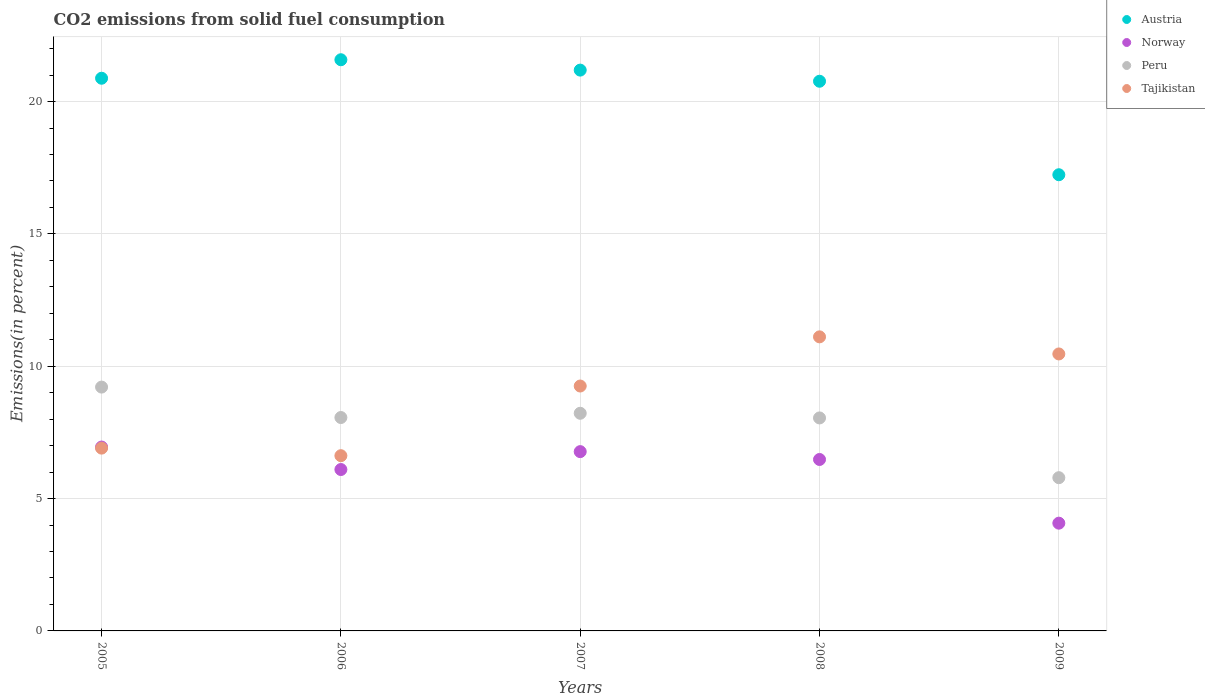Is the number of dotlines equal to the number of legend labels?
Your response must be concise. Yes. What is the total CO2 emitted in Austria in 2009?
Offer a terse response. 17.24. Across all years, what is the maximum total CO2 emitted in Norway?
Provide a short and direct response. 6.95. Across all years, what is the minimum total CO2 emitted in Norway?
Offer a terse response. 4.07. What is the total total CO2 emitted in Austria in the graph?
Provide a succinct answer. 101.66. What is the difference between the total CO2 emitted in Norway in 2008 and that in 2009?
Keep it short and to the point. 2.41. What is the difference between the total CO2 emitted in Austria in 2009 and the total CO2 emitted in Norway in 2007?
Offer a very short reply. 10.46. What is the average total CO2 emitted in Austria per year?
Your answer should be very brief. 20.33. In the year 2007, what is the difference between the total CO2 emitted in Austria and total CO2 emitted in Tajikistan?
Provide a succinct answer. 11.94. What is the ratio of the total CO2 emitted in Tajikistan in 2006 to that in 2008?
Offer a terse response. 0.6. Is the difference between the total CO2 emitted in Austria in 2005 and 2006 greater than the difference between the total CO2 emitted in Tajikistan in 2005 and 2006?
Your response must be concise. No. What is the difference between the highest and the second highest total CO2 emitted in Tajikistan?
Give a very brief answer. 0.65. What is the difference between the highest and the lowest total CO2 emitted in Tajikistan?
Give a very brief answer. 4.49. In how many years, is the total CO2 emitted in Austria greater than the average total CO2 emitted in Austria taken over all years?
Your answer should be very brief. 4. Is the sum of the total CO2 emitted in Norway in 2005 and 2008 greater than the maximum total CO2 emitted in Austria across all years?
Your answer should be very brief. No. Is it the case that in every year, the sum of the total CO2 emitted in Austria and total CO2 emitted in Norway  is greater than the total CO2 emitted in Tajikistan?
Your answer should be very brief. Yes. Is the total CO2 emitted in Peru strictly less than the total CO2 emitted in Norway over the years?
Offer a very short reply. No. How many dotlines are there?
Ensure brevity in your answer.  4. What is the difference between two consecutive major ticks on the Y-axis?
Keep it short and to the point. 5. Does the graph contain any zero values?
Provide a succinct answer. No. Does the graph contain grids?
Your answer should be compact. Yes. Where does the legend appear in the graph?
Your response must be concise. Top right. How are the legend labels stacked?
Ensure brevity in your answer.  Vertical. What is the title of the graph?
Keep it short and to the point. CO2 emissions from solid fuel consumption. What is the label or title of the X-axis?
Give a very brief answer. Years. What is the label or title of the Y-axis?
Ensure brevity in your answer.  Emissions(in percent). What is the Emissions(in percent) in Austria in 2005?
Provide a succinct answer. 20.88. What is the Emissions(in percent) in Norway in 2005?
Offer a terse response. 6.95. What is the Emissions(in percent) of Peru in 2005?
Your response must be concise. 9.21. What is the Emissions(in percent) in Tajikistan in 2005?
Keep it short and to the point. 6.91. What is the Emissions(in percent) of Austria in 2006?
Make the answer very short. 21.58. What is the Emissions(in percent) in Norway in 2006?
Make the answer very short. 6.1. What is the Emissions(in percent) of Peru in 2006?
Provide a short and direct response. 8.06. What is the Emissions(in percent) in Tajikistan in 2006?
Keep it short and to the point. 6.62. What is the Emissions(in percent) of Austria in 2007?
Provide a short and direct response. 21.19. What is the Emissions(in percent) of Norway in 2007?
Keep it short and to the point. 6.77. What is the Emissions(in percent) of Peru in 2007?
Provide a short and direct response. 8.22. What is the Emissions(in percent) in Tajikistan in 2007?
Provide a short and direct response. 9.25. What is the Emissions(in percent) of Austria in 2008?
Your answer should be very brief. 20.77. What is the Emissions(in percent) in Norway in 2008?
Your response must be concise. 6.48. What is the Emissions(in percent) of Peru in 2008?
Make the answer very short. 8.05. What is the Emissions(in percent) in Tajikistan in 2008?
Offer a very short reply. 11.11. What is the Emissions(in percent) in Austria in 2009?
Give a very brief answer. 17.24. What is the Emissions(in percent) in Norway in 2009?
Provide a short and direct response. 4.07. What is the Emissions(in percent) of Peru in 2009?
Give a very brief answer. 5.79. What is the Emissions(in percent) of Tajikistan in 2009?
Keep it short and to the point. 10.47. Across all years, what is the maximum Emissions(in percent) of Austria?
Offer a very short reply. 21.58. Across all years, what is the maximum Emissions(in percent) of Norway?
Make the answer very short. 6.95. Across all years, what is the maximum Emissions(in percent) in Peru?
Make the answer very short. 9.21. Across all years, what is the maximum Emissions(in percent) of Tajikistan?
Your answer should be compact. 11.11. Across all years, what is the minimum Emissions(in percent) in Austria?
Ensure brevity in your answer.  17.24. Across all years, what is the minimum Emissions(in percent) in Norway?
Your response must be concise. 4.07. Across all years, what is the minimum Emissions(in percent) of Peru?
Keep it short and to the point. 5.79. Across all years, what is the minimum Emissions(in percent) of Tajikistan?
Provide a succinct answer. 6.62. What is the total Emissions(in percent) in Austria in the graph?
Your answer should be compact. 101.66. What is the total Emissions(in percent) in Norway in the graph?
Your answer should be compact. 30.37. What is the total Emissions(in percent) in Peru in the graph?
Your response must be concise. 39.34. What is the total Emissions(in percent) in Tajikistan in the graph?
Offer a very short reply. 44.36. What is the difference between the Emissions(in percent) of Austria in 2005 and that in 2006?
Keep it short and to the point. -0.7. What is the difference between the Emissions(in percent) of Norway in 2005 and that in 2006?
Your answer should be very brief. 0.85. What is the difference between the Emissions(in percent) of Peru in 2005 and that in 2006?
Your answer should be compact. 1.15. What is the difference between the Emissions(in percent) in Tajikistan in 2005 and that in 2006?
Make the answer very short. 0.29. What is the difference between the Emissions(in percent) of Austria in 2005 and that in 2007?
Your answer should be very brief. -0.31. What is the difference between the Emissions(in percent) in Norway in 2005 and that in 2007?
Offer a terse response. 0.17. What is the difference between the Emissions(in percent) in Peru in 2005 and that in 2007?
Provide a short and direct response. 0.99. What is the difference between the Emissions(in percent) in Tajikistan in 2005 and that in 2007?
Provide a short and direct response. -2.35. What is the difference between the Emissions(in percent) in Austria in 2005 and that in 2008?
Make the answer very short. 0.11. What is the difference between the Emissions(in percent) in Norway in 2005 and that in 2008?
Provide a succinct answer. 0.47. What is the difference between the Emissions(in percent) in Peru in 2005 and that in 2008?
Give a very brief answer. 1.17. What is the difference between the Emissions(in percent) in Tajikistan in 2005 and that in 2008?
Ensure brevity in your answer.  -4.2. What is the difference between the Emissions(in percent) in Austria in 2005 and that in 2009?
Offer a very short reply. 3.65. What is the difference between the Emissions(in percent) of Norway in 2005 and that in 2009?
Your response must be concise. 2.88. What is the difference between the Emissions(in percent) in Peru in 2005 and that in 2009?
Offer a very short reply. 3.42. What is the difference between the Emissions(in percent) in Tajikistan in 2005 and that in 2009?
Your response must be concise. -3.56. What is the difference between the Emissions(in percent) of Austria in 2006 and that in 2007?
Your answer should be compact. 0.39. What is the difference between the Emissions(in percent) of Norway in 2006 and that in 2007?
Keep it short and to the point. -0.68. What is the difference between the Emissions(in percent) in Peru in 2006 and that in 2007?
Your response must be concise. -0.16. What is the difference between the Emissions(in percent) in Tajikistan in 2006 and that in 2007?
Provide a succinct answer. -2.63. What is the difference between the Emissions(in percent) of Austria in 2006 and that in 2008?
Your answer should be compact. 0.81. What is the difference between the Emissions(in percent) of Norway in 2006 and that in 2008?
Make the answer very short. -0.38. What is the difference between the Emissions(in percent) in Peru in 2006 and that in 2008?
Offer a terse response. 0.02. What is the difference between the Emissions(in percent) of Tajikistan in 2006 and that in 2008?
Offer a very short reply. -4.49. What is the difference between the Emissions(in percent) in Austria in 2006 and that in 2009?
Give a very brief answer. 4.34. What is the difference between the Emissions(in percent) of Norway in 2006 and that in 2009?
Make the answer very short. 2.03. What is the difference between the Emissions(in percent) of Peru in 2006 and that in 2009?
Make the answer very short. 2.27. What is the difference between the Emissions(in percent) of Tajikistan in 2006 and that in 2009?
Make the answer very short. -3.84. What is the difference between the Emissions(in percent) of Austria in 2007 and that in 2008?
Ensure brevity in your answer.  0.42. What is the difference between the Emissions(in percent) of Norway in 2007 and that in 2008?
Provide a short and direct response. 0.3. What is the difference between the Emissions(in percent) of Peru in 2007 and that in 2008?
Your response must be concise. 0.18. What is the difference between the Emissions(in percent) of Tajikistan in 2007 and that in 2008?
Make the answer very short. -1.86. What is the difference between the Emissions(in percent) of Austria in 2007 and that in 2009?
Make the answer very short. 3.95. What is the difference between the Emissions(in percent) in Norway in 2007 and that in 2009?
Provide a short and direct response. 2.7. What is the difference between the Emissions(in percent) in Peru in 2007 and that in 2009?
Make the answer very short. 2.43. What is the difference between the Emissions(in percent) of Tajikistan in 2007 and that in 2009?
Give a very brief answer. -1.21. What is the difference between the Emissions(in percent) in Austria in 2008 and that in 2009?
Offer a terse response. 3.53. What is the difference between the Emissions(in percent) of Norway in 2008 and that in 2009?
Keep it short and to the point. 2.41. What is the difference between the Emissions(in percent) in Peru in 2008 and that in 2009?
Keep it short and to the point. 2.26. What is the difference between the Emissions(in percent) of Tajikistan in 2008 and that in 2009?
Provide a short and direct response. 0.65. What is the difference between the Emissions(in percent) in Austria in 2005 and the Emissions(in percent) in Norway in 2006?
Ensure brevity in your answer.  14.78. What is the difference between the Emissions(in percent) of Austria in 2005 and the Emissions(in percent) of Peru in 2006?
Give a very brief answer. 12.82. What is the difference between the Emissions(in percent) of Austria in 2005 and the Emissions(in percent) of Tajikistan in 2006?
Offer a very short reply. 14.26. What is the difference between the Emissions(in percent) in Norway in 2005 and the Emissions(in percent) in Peru in 2006?
Your answer should be very brief. -1.12. What is the difference between the Emissions(in percent) in Norway in 2005 and the Emissions(in percent) in Tajikistan in 2006?
Offer a very short reply. 0.33. What is the difference between the Emissions(in percent) of Peru in 2005 and the Emissions(in percent) of Tajikistan in 2006?
Make the answer very short. 2.59. What is the difference between the Emissions(in percent) of Austria in 2005 and the Emissions(in percent) of Norway in 2007?
Offer a terse response. 14.11. What is the difference between the Emissions(in percent) of Austria in 2005 and the Emissions(in percent) of Peru in 2007?
Ensure brevity in your answer.  12.66. What is the difference between the Emissions(in percent) of Austria in 2005 and the Emissions(in percent) of Tajikistan in 2007?
Ensure brevity in your answer.  11.63. What is the difference between the Emissions(in percent) of Norway in 2005 and the Emissions(in percent) of Peru in 2007?
Keep it short and to the point. -1.28. What is the difference between the Emissions(in percent) of Norway in 2005 and the Emissions(in percent) of Tajikistan in 2007?
Offer a very short reply. -2.31. What is the difference between the Emissions(in percent) of Peru in 2005 and the Emissions(in percent) of Tajikistan in 2007?
Your answer should be compact. -0.04. What is the difference between the Emissions(in percent) in Austria in 2005 and the Emissions(in percent) in Norway in 2008?
Provide a succinct answer. 14.4. What is the difference between the Emissions(in percent) in Austria in 2005 and the Emissions(in percent) in Peru in 2008?
Ensure brevity in your answer.  12.84. What is the difference between the Emissions(in percent) in Austria in 2005 and the Emissions(in percent) in Tajikistan in 2008?
Your answer should be very brief. 9.77. What is the difference between the Emissions(in percent) in Norway in 2005 and the Emissions(in percent) in Peru in 2008?
Ensure brevity in your answer.  -1.1. What is the difference between the Emissions(in percent) in Norway in 2005 and the Emissions(in percent) in Tajikistan in 2008?
Give a very brief answer. -4.16. What is the difference between the Emissions(in percent) of Peru in 2005 and the Emissions(in percent) of Tajikistan in 2008?
Give a very brief answer. -1.9. What is the difference between the Emissions(in percent) of Austria in 2005 and the Emissions(in percent) of Norway in 2009?
Provide a short and direct response. 16.81. What is the difference between the Emissions(in percent) of Austria in 2005 and the Emissions(in percent) of Peru in 2009?
Provide a succinct answer. 15.09. What is the difference between the Emissions(in percent) of Austria in 2005 and the Emissions(in percent) of Tajikistan in 2009?
Provide a short and direct response. 10.42. What is the difference between the Emissions(in percent) in Norway in 2005 and the Emissions(in percent) in Peru in 2009?
Keep it short and to the point. 1.16. What is the difference between the Emissions(in percent) of Norway in 2005 and the Emissions(in percent) of Tajikistan in 2009?
Your response must be concise. -3.52. What is the difference between the Emissions(in percent) in Peru in 2005 and the Emissions(in percent) in Tajikistan in 2009?
Your response must be concise. -1.25. What is the difference between the Emissions(in percent) of Austria in 2006 and the Emissions(in percent) of Norway in 2007?
Give a very brief answer. 14.81. What is the difference between the Emissions(in percent) in Austria in 2006 and the Emissions(in percent) in Peru in 2007?
Make the answer very short. 13.36. What is the difference between the Emissions(in percent) of Austria in 2006 and the Emissions(in percent) of Tajikistan in 2007?
Provide a succinct answer. 12.33. What is the difference between the Emissions(in percent) in Norway in 2006 and the Emissions(in percent) in Peru in 2007?
Make the answer very short. -2.13. What is the difference between the Emissions(in percent) in Norway in 2006 and the Emissions(in percent) in Tajikistan in 2007?
Your answer should be very brief. -3.15. What is the difference between the Emissions(in percent) of Peru in 2006 and the Emissions(in percent) of Tajikistan in 2007?
Provide a succinct answer. -1.19. What is the difference between the Emissions(in percent) of Austria in 2006 and the Emissions(in percent) of Norway in 2008?
Provide a succinct answer. 15.1. What is the difference between the Emissions(in percent) of Austria in 2006 and the Emissions(in percent) of Peru in 2008?
Offer a very short reply. 13.53. What is the difference between the Emissions(in percent) of Austria in 2006 and the Emissions(in percent) of Tajikistan in 2008?
Offer a very short reply. 10.47. What is the difference between the Emissions(in percent) of Norway in 2006 and the Emissions(in percent) of Peru in 2008?
Provide a short and direct response. -1.95. What is the difference between the Emissions(in percent) in Norway in 2006 and the Emissions(in percent) in Tajikistan in 2008?
Make the answer very short. -5.01. What is the difference between the Emissions(in percent) in Peru in 2006 and the Emissions(in percent) in Tajikistan in 2008?
Your response must be concise. -3.05. What is the difference between the Emissions(in percent) of Austria in 2006 and the Emissions(in percent) of Norway in 2009?
Your answer should be very brief. 17.51. What is the difference between the Emissions(in percent) in Austria in 2006 and the Emissions(in percent) in Peru in 2009?
Make the answer very short. 15.79. What is the difference between the Emissions(in percent) in Austria in 2006 and the Emissions(in percent) in Tajikistan in 2009?
Make the answer very short. 11.12. What is the difference between the Emissions(in percent) of Norway in 2006 and the Emissions(in percent) of Peru in 2009?
Your answer should be compact. 0.31. What is the difference between the Emissions(in percent) in Norway in 2006 and the Emissions(in percent) in Tajikistan in 2009?
Offer a terse response. -4.37. What is the difference between the Emissions(in percent) in Peru in 2006 and the Emissions(in percent) in Tajikistan in 2009?
Make the answer very short. -2.4. What is the difference between the Emissions(in percent) of Austria in 2007 and the Emissions(in percent) of Norway in 2008?
Offer a terse response. 14.71. What is the difference between the Emissions(in percent) of Austria in 2007 and the Emissions(in percent) of Peru in 2008?
Give a very brief answer. 13.14. What is the difference between the Emissions(in percent) in Austria in 2007 and the Emissions(in percent) in Tajikistan in 2008?
Your response must be concise. 10.08. What is the difference between the Emissions(in percent) of Norway in 2007 and the Emissions(in percent) of Peru in 2008?
Keep it short and to the point. -1.27. What is the difference between the Emissions(in percent) of Norway in 2007 and the Emissions(in percent) of Tajikistan in 2008?
Provide a short and direct response. -4.34. What is the difference between the Emissions(in percent) of Peru in 2007 and the Emissions(in percent) of Tajikistan in 2008?
Offer a very short reply. -2.89. What is the difference between the Emissions(in percent) of Austria in 2007 and the Emissions(in percent) of Norway in 2009?
Offer a terse response. 17.12. What is the difference between the Emissions(in percent) of Austria in 2007 and the Emissions(in percent) of Peru in 2009?
Your answer should be very brief. 15.4. What is the difference between the Emissions(in percent) in Austria in 2007 and the Emissions(in percent) in Tajikistan in 2009?
Give a very brief answer. 10.72. What is the difference between the Emissions(in percent) of Norway in 2007 and the Emissions(in percent) of Peru in 2009?
Ensure brevity in your answer.  0.98. What is the difference between the Emissions(in percent) in Norway in 2007 and the Emissions(in percent) in Tajikistan in 2009?
Ensure brevity in your answer.  -3.69. What is the difference between the Emissions(in percent) of Peru in 2007 and the Emissions(in percent) of Tajikistan in 2009?
Make the answer very short. -2.24. What is the difference between the Emissions(in percent) in Austria in 2008 and the Emissions(in percent) in Norway in 2009?
Offer a terse response. 16.7. What is the difference between the Emissions(in percent) in Austria in 2008 and the Emissions(in percent) in Peru in 2009?
Give a very brief answer. 14.98. What is the difference between the Emissions(in percent) of Austria in 2008 and the Emissions(in percent) of Tajikistan in 2009?
Your answer should be very brief. 10.3. What is the difference between the Emissions(in percent) of Norway in 2008 and the Emissions(in percent) of Peru in 2009?
Ensure brevity in your answer.  0.69. What is the difference between the Emissions(in percent) of Norway in 2008 and the Emissions(in percent) of Tajikistan in 2009?
Give a very brief answer. -3.99. What is the difference between the Emissions(in percent) of Peru in 2008 and the Emissions(in percent) of Tajikistan in 2009?
Offer a very short reply. -2.42. What is the average Emissions(in percent) in Austria per year?
Offer a very short reply. 20.33. What is the average Emissions(in percent) of Norway per year?
Provide a succinct answer. 6.07. What is the average Emissions(in percent) of Peru per year?
Keep it short and to the point. 7.87. What is the average Emissions(in percent) in Tajikistan per year?
Your answer should be compact. 8.87. In the year 2005, what is the difference between the Emissions(in percent) in Austria and Emissions(in percent) in Norway?
Keep it short and to the point. 13.94. In the year 2005, what is the difference between the Emissions(in percent) in Austria and Emissions(in percent) in Peru?
Give a very brief answer. 11.67. In the year 2005, what is the difference between the Emissions(in percent) in Austria and Emissions(in percent) in Tajikistan?
Offer a terse response. 13.98. In the year 2005, what is the difference between the Emissions(in percent) in Norway and Emissions(in percent) in Peru?
Offer a very short reply. -2.27. In the year 2005, what is the difference between the Emissions(in percent) in Norway and Emissions(in percent) in Tajikistan?
Your answer should be very brief. 0.04. In the year 2005, what is the difference between the Emissions(in percent) in Peru and Emissions(in percent) in Tajikistan?
Your answer should be compact. 2.31. In the year 2006, what is the difference between the Emissions(in percent) of Austria and Emissions(in percent) of Norway?
Your answer should be very brief. 15.48. In the year 2006, what is the difference between the Emissions(in percent) in Austria and Emissions(in percent) in Peru?
Your answer should be compact. 13.52. In the year 2006, what is the difference between the Emissions(in percent) of Austria and Emissions(in percent) of Tajikistan?
Provide a short and direct response. 14.96. In the year 2006, what is the difference between the Emissions(in percent) in Norway and Emissions(in percent) in Peru?
Offer a terse response. -1.96. In the year 2006, what is the difference between the Emissions(in percent) in Norway and Emissions(in percent) in Tajikistan?
Give a very brief answer. -0.52. In the year 2006, what is the difference between the Emissions(in percent) of Peru and Emissions(in percent) of Tajikistan?
Your answer should be very brief. 1.44. In the year 2007, what is the difference between the Emissions(in percent) of Austria and Emissions(in percent) of Norway?
Offer a very short reply. 14.42. In the year 2007, what is the difference between the Emissions(in percent) of Austria and Emissions(in percent) of Peru?
Your answer should be compact. 12.97. In the year 2007, what is the difference between the Emissions(in percent) in Austria and Emissions(in percent) in Tajikistan?
Provide a succinct answer. 11.94. In the year 2007, what is the difference between the Emissions(in percent) in Norway and Emissions(in percent) in Peru?
Offer a very short reply. -1.45. In the year 2007, what is the difference between the Emissions(in percent) of Norway and Emissions(in percent) of Tajikistan?
Make the answer very short. -2.48. In the year 2007, what is the difference between the Emissions(in percent) in Peru and Emissions(in percent) in Tajikistan?
Offer a terse response. -1.03. In the year 2008, what is the difference between the Emissions(in percent) of Austria and Emissions(in percent) of Norway?
Your response must be concise. 14.29. In the year 2008, what is the difference between the Emissions(in percent) of Austria and Emissions(in percent) of Peru?
Keep it short and to the point. 12.72. In the year 2008, what is the difference between the Emissions(in percent) of Austria and Emissions(in percent) of Tajikistan?
Make the answer very short. 9.66. In the year 2008, what is the difference between the Emissions(in percent) in Norway and Emissions(in percent) in Peru?
Your response must be concise. -1.57. In the year 2008, what is the difference between the Emissions(in percent) in Norway and Emissions(in percent) in Tajikistan?
Provide a succinct answer. -4.63. In the year 2008, what is the difference between the Emissions(in percent) in Peru and Emissions(in percent) in Tajikistan?
Ensure brevity in your answer.  -3.06. In the year 2009, what is the difference between the Emissions(in percent) in Austria and Emissions(in percent) in Norway?
Give a very brief answer. 13.17. In the year 2009, what is the difference between the Emissions(in percent) in Austria and Emissions(in percent) in Peru?
Your answer should be compact. 11.45. In the year 2009, what is the difference between the Emissions(in percent) of Austria and Emissions(in percent) of Tajikistan?
Give a very brief answer. 6.77. In the year 2009, what is the difference between the Emissions(in percent) in Norway and Emissions(in percent) in Peru?
Your answer should be very brief. -1.72. In the year 2009, what is the difference between the Emissions(in percent) in Norway and Emissions(in percent) in Tajikistan?
Keep it short and to the point. -6.39. In the year 2009, what is the difference between the Emissions(in percent) of Peru and Emissions(in percent) of Tajikistan?
Give a very brief answer. -4.68. What is the ratio of the Emissions(in percent) in Austria in 2005 to that in 2006?
Offer a terse response. 0.97. What is the ratio of the Emissions(in percent) in Norway in 2005 to that in 2006?
Make the answer very short. 1.14. What is the ratio of the Emissions(in percent) in Peru in 2005 to that in 2006?
Make the answer very short. 1.14. What is the ratio of the Emissions(in percent) in Tajikistan in 2005 to that in 2006?
Provide a succinct answer. 1.04. What is the ratio of the Emissions(in percent) of Austria in 2005 to that in 2007?
Provide a short and direct response. 0.99. What is the ratio of the Emissions(in percent) of Norway in 2005 to that in 2007?
Offer a very short reply. 1.03. What is the ratio of the Emissions(in percent) of Peru in 2005 to that in 2007?
Make the answer very short. 1.12. What is the ratio of the Emissions(in percent) in Tajikistan in 2005 to that in 2007?
Offer a very short reply. 0.75. What is the ratio of the Emissions(in percent) in Norway in 2005 to that in 2008?
Provide a short and direct response. 1.07. What is the ratio of the Emissions(in percent) of Peru in 2005 to that in 2008?
Your response must be concise. 1.14. What is the ratio of the Emissions(in percent) in Tajikistan in 2005 to that in 2008?
Provide a succinct answer. 0.62. What is the ratio of the Emissions(in percent) in Austria in 2005 to that in 2009?
Ensure brevity in your answer.  1.21. What is the ratio of the Emissions(in percent) in Norway in 2005 to that in 2009?
Give a very brief answer. 1.71. What is the ratio of the Emissions(in percent) in Peru in 2005 to that in 2009?
Keep it short and to the point. 1.59. What is the ratio of the Emissions(in percent) in Tajikistan in 2005 to that in 2009?
Make the answer very short. 0.66. What is the ratio of the Emissions(in percent) of Austria in 2006 to that in 2007?
Give a very brief answer. 1.02. What is the ratio of the Emissions(in percent) in Norway in 2006 to that in 2007?
Offer a very short reply. 0.9. What is the ratio of the Emissions(in percent) in Peru in 2006 to that in 2007?
Your answer should be very brief. 0.98. What is the ratio of the Emissions(in percent) in Tajikistan in 2006 to that in 2007?
Make the answer very short. 0.72. What is the ratio of the Emissions(in percent) of Austria in 2006 to that in 2008?
Provide a succinct answer. 1.04. What is the ratio of the Emissions(in percent) in Norway in 2006 to that in 2008?
Your response must be concise. 0.94. What is the ratio of the Emissions(in percent) of Tajikistan in 2006 to that in 2008?
Make the answer very short. 0.6. What is the ratio of the Emissions(in percent) of Austria in 2006 to that in 2009?
Your answer should be compact. 1.25. What is the ratio of the Emissions(in percent) in Norway in 2006 to that in 2009?
Give a very brief answer. 1.5. What is the ratio of the Emissions(in percent) in Peru in 2006 to that in 2009?
Keep it short and to the point. 1.39. What is the ratio of the Emissions(in percent) in Tajikistan in 2006 to that in 2009?
Provide a short and direct response. 0.63. What is the ratio of the Emissions(in percent) of Austria in 2007 to that in 2008?
Offer a terse response. 1.02. What is the ratio of the Emissions(in percent) of Norway in 2007 to that in 2008?
Your answer should be very brief. 1.05. What is the ratio of the Emissions(in percent) in Peru in 2007 to that in 2008?
Give a very brief answer. 1.02. What is the ratio of the Emissions(in percent) of Tajikistan in 2007 to that in 2008?
Provide a short and direct response. 0.83. What is the ratio of the Emissions(in percent) of Austria in 2007 to that in 2009?
Offer a very short reply. 1.23. What is the ratio of the Emissions(in percent) in Norway in 2007 to that in 2009?
Keep it short and to the point. 1.66. What is the ratio of the Emissions(in percent) of Peru in 2007 to that in 2009?
Offer a very short reply. 1.42. What is the ratio of the Emissions(in percent) in Tajikistan in 2007 to that in 2009?
Make the answer very short. 0.88. What is the ratio of the Emissions(in percent) in Austria in 2008 to that in 2009?
Your response must be concise. 1.2. What is the ratio of the Emissions(in percent) of Norway in 2008 to that in 2009?
Offer a very short reply. 1.59. What is the ratio of the Emissions(in percent) of Peru in 2008 to that in 2009?
Provide a short and direct response. 1.39. What is the ratio of the Emissions(in percent) in Tajikistan in 2008 to that in 2009?
Ensure brevity in your answer.  1.06. What is the difference between the highest and the second highest Emissions(in percent) of Austria?
Your answer should be compact. 0.39. What is the difference between the highest and the second highest Emissions(in percent) in Norway?
Your answer should be compact. 0.17. What is the difference between the highest and the second highest Emissions(in percent) of Peru?
Offer a very short reply. 0.99. What is the difference between the highest and the second highest Emissions(in percent) of Tajikistan?
Your answer should be compact. 0.65. What is the difference between the highest and the lowest Emissions(in percent) in Austria?
Ensure brevity in your answer.  4.34. What is the difference between the highest and the lowest Emissions(in percent) in Norway?
Your answer should be very brief. 2.88. What is the difference between the highest and the lowest Emissions(in percent) in Peru?
Provide a short and direct response. 3.42. What is the difference between the highest and the lowest Emissions(in percent) in Tajikistan?
Give a very brief answer. 4.49. 